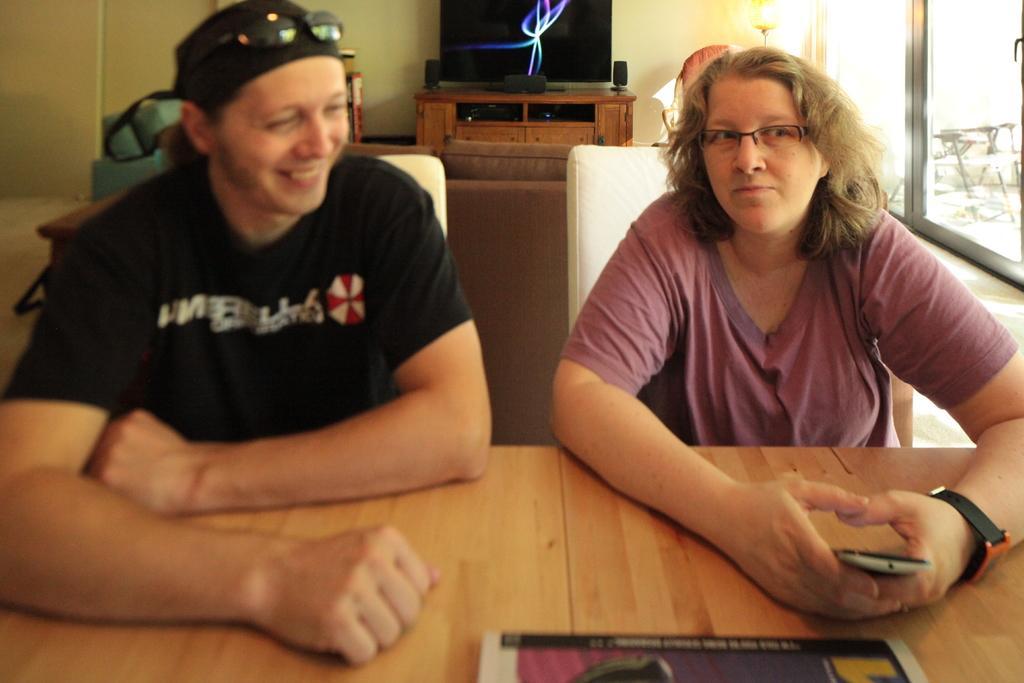Describe this image in one or two sentences. In this image we can see two persons sitting in front of the table. One person wearing spectacles is holding a mobile in his hand. In the background, we can see a sofa, television on the cupboard and group of speakers and windows. 